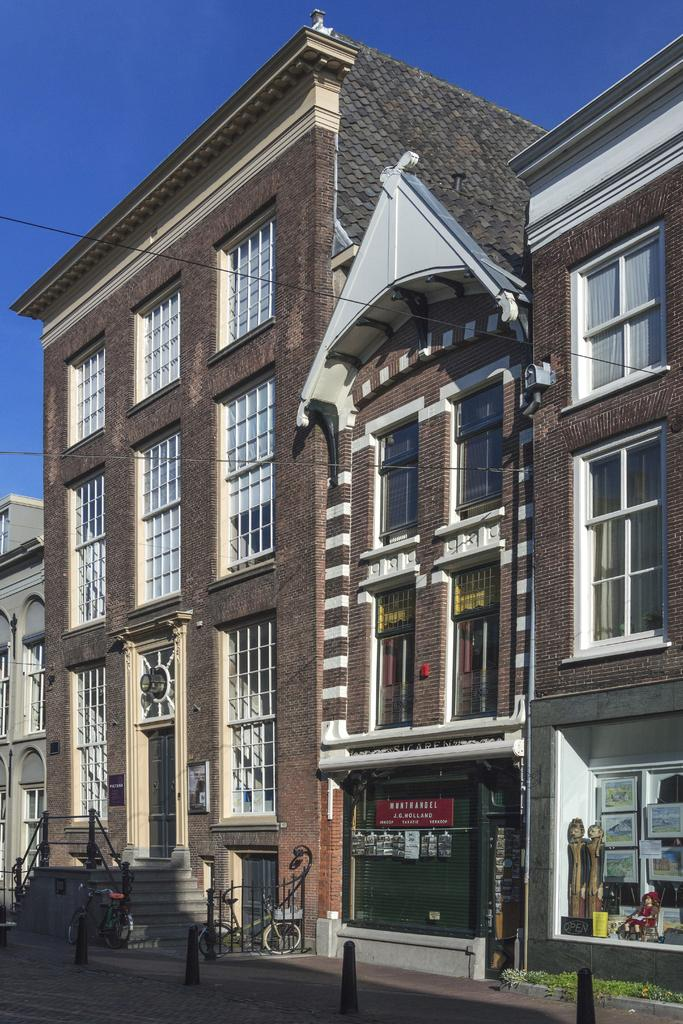What is the color of the sky in the image? The sky is blue in the image. What type of structures can be seen in the image? There are buildings in the image. What architectural feature is present in the image? There are steps in the image. What mode of transportation is visible in the image? There are bicycles in the image. What type of objects can be seen hanging on the walls in the image? There are pictures in the image. How many girls are playing with the force in the image? There are no girls or any reference to force in the image. What type of acoustics can be heard in the image? There is no sound or acoustics mentioned in the image, as it is a still picture. 